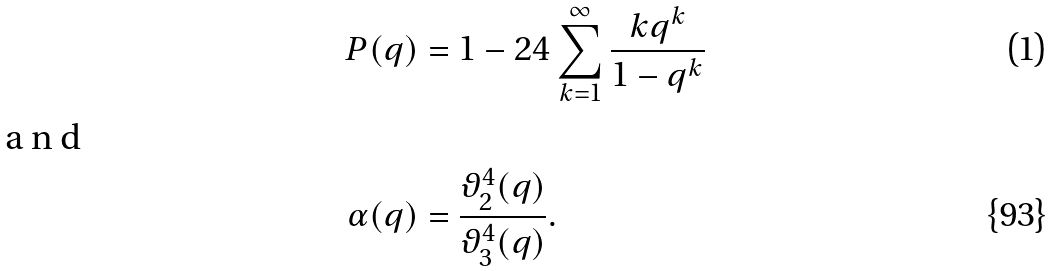<formula> <loc_0><loc_0><loc_500><loc_500>P ( q ) & = 1 - 2 4 \sum _ { k = 1 } ^ { \infty } \frac { k q ^ { k } } { 1 - q ^ { k } } \intertext { a n d } \alpha ( q ) & = \frac { \vartheta _ { 2 } ^ { 4 } ( q ) } { \vartheta _ { 3 } ^ { 4 } ( q ) } .</formula> 